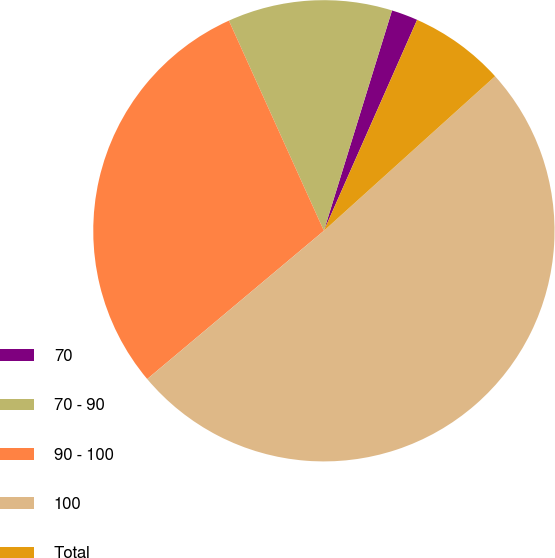<chart> <loc_0><loc_0><loc_500><loc_500><pie_chart><fcel>70<fcel>70 - 90<fcel>90 - 100<fcel>100<fcel>Total<nl><fcel>1.85%<fcel>11.53%<fcel>29.35%<fcel>50.57%<fcel>6.69%<nl></chart> 